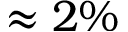<formula> <loc_0><loc_0><loc_500><loc_500>\approx 2 \%</formula> 